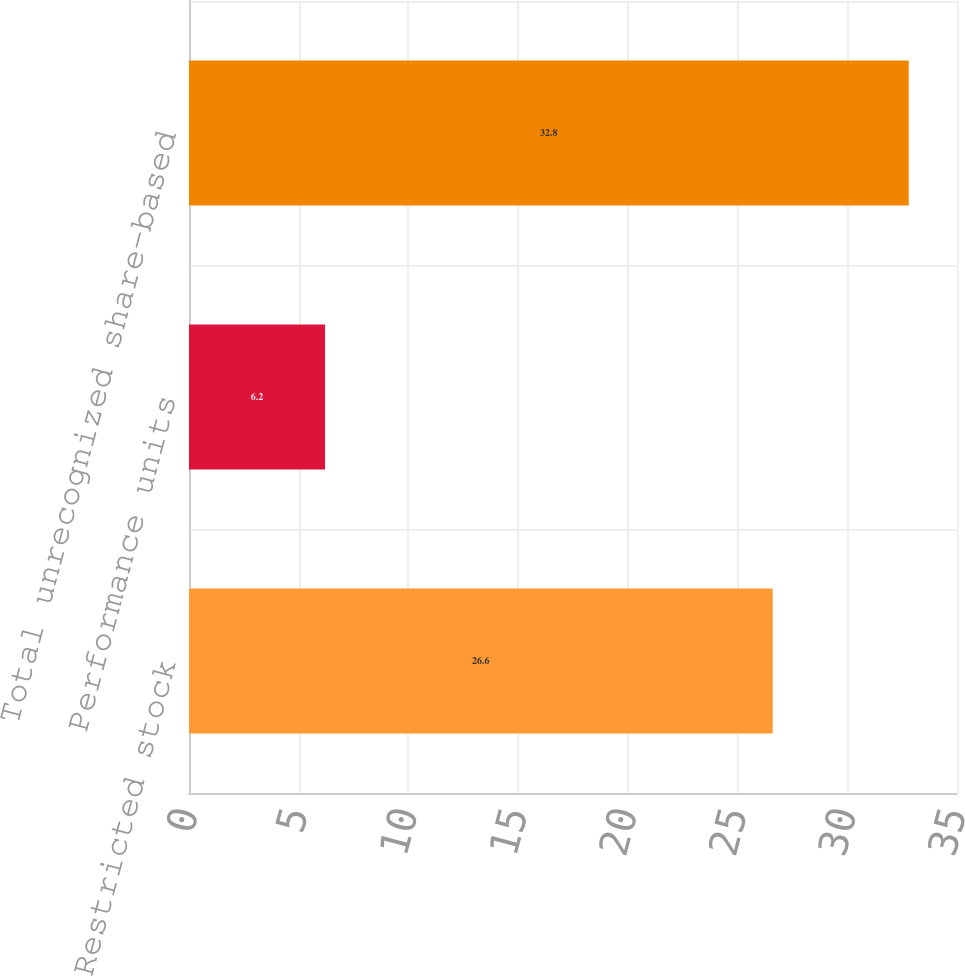Convert chart. <chart><loc_0><loc_0><loc_500><loc_500><bar_chart><fcel>Restricted stock<fcel>Performance units<fcel>Total unrecognized share-based<nl><fcel>26.6<fcel>6.2<fcel>32.8<nl></chart> 